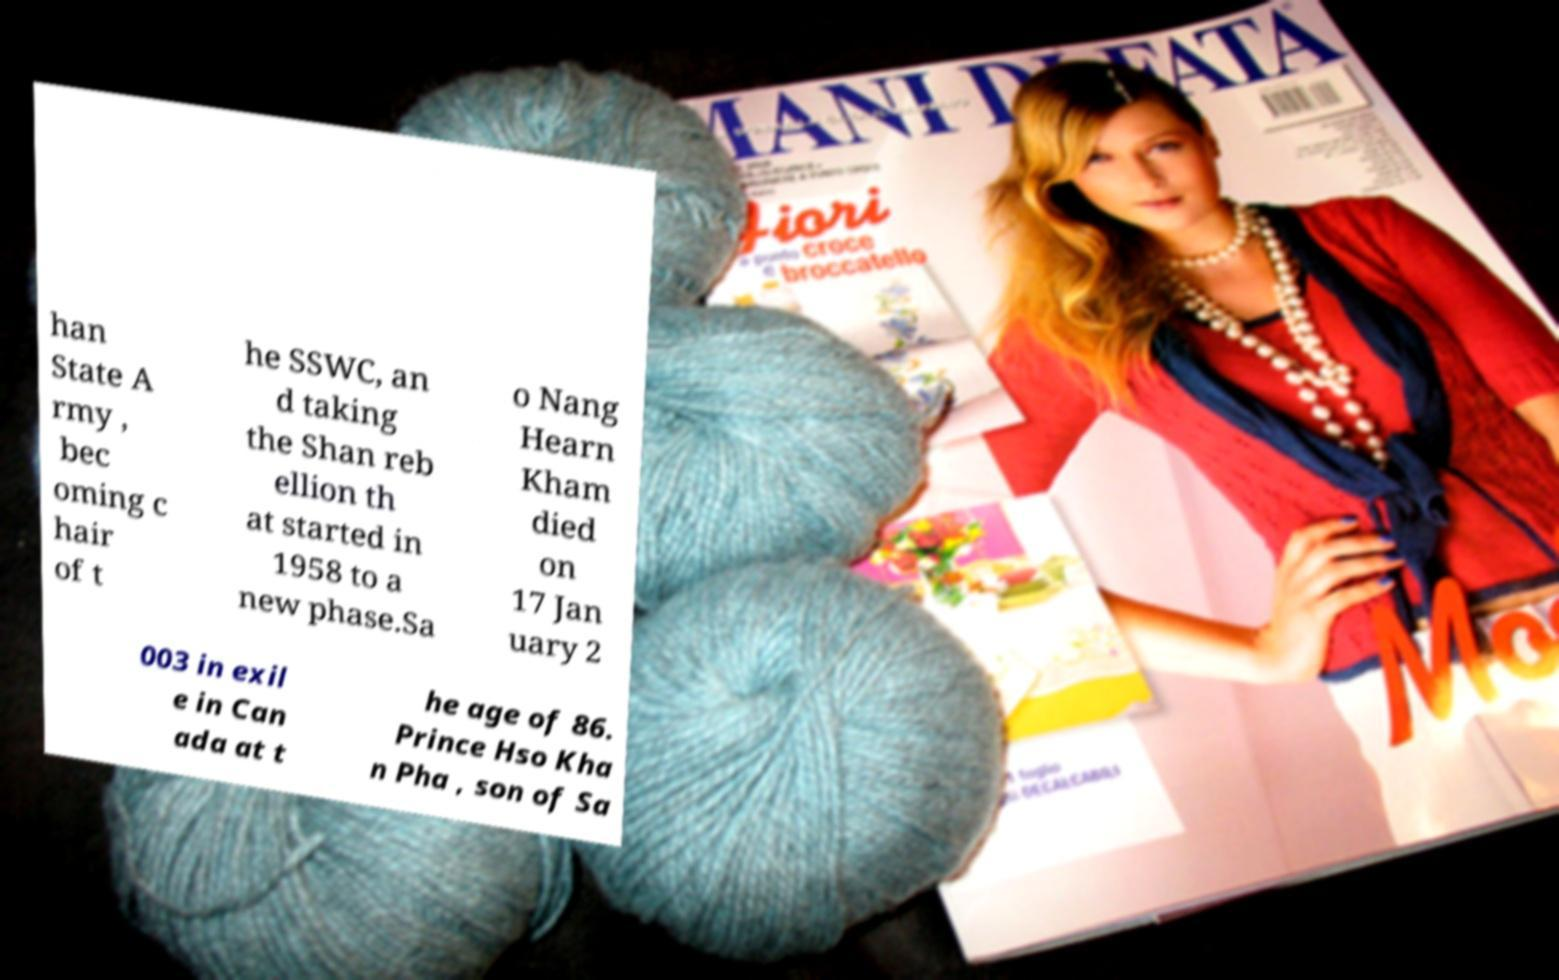There's text embedded in this image that I need extracted. Can you transcribe it verbatim? han State A rmy , bec oming c hair of t he SSWC, an d taking the Shan reb ellion th at started in 1958 to a new phase.Sa o Nang Hearn Kham died on 17 Jan uary 2 003 in exil e in Can ada at t he age of 86. Prince Hso Kha n Pha , son of Sa 